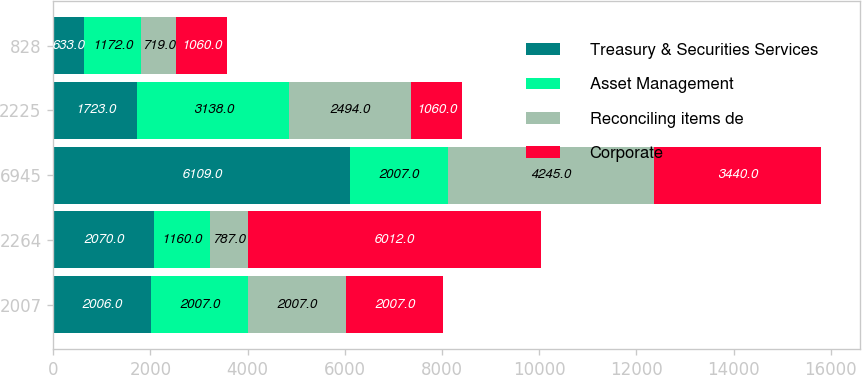Convert chart to OTSL. <chart><loc_0><loc_0><loc_500><loc_500><stacked_bar_chart><ecel><fcel>2007<fcel>2264<fcel>6945<fcel>2225<fcel>828<nl><fcel>Treasury & Securities Services<fcel>2006<fcel>2070<fcel>6109<fcel>1723<fcel>633<nl><fcel>Asset Management<fcel>2007<fcel>1160<fcel>2007<fcel>3138<fcel>1172<nl><fcel>Reconciling items de<fcel>2007<fcel>787<fcel>4245<fcel>2494<fcel>719<nl><fcel>Corporate<fcel>2007<fcel>6012<fcel>3440<fcel>1060<fcel>1060<nl></chart> 